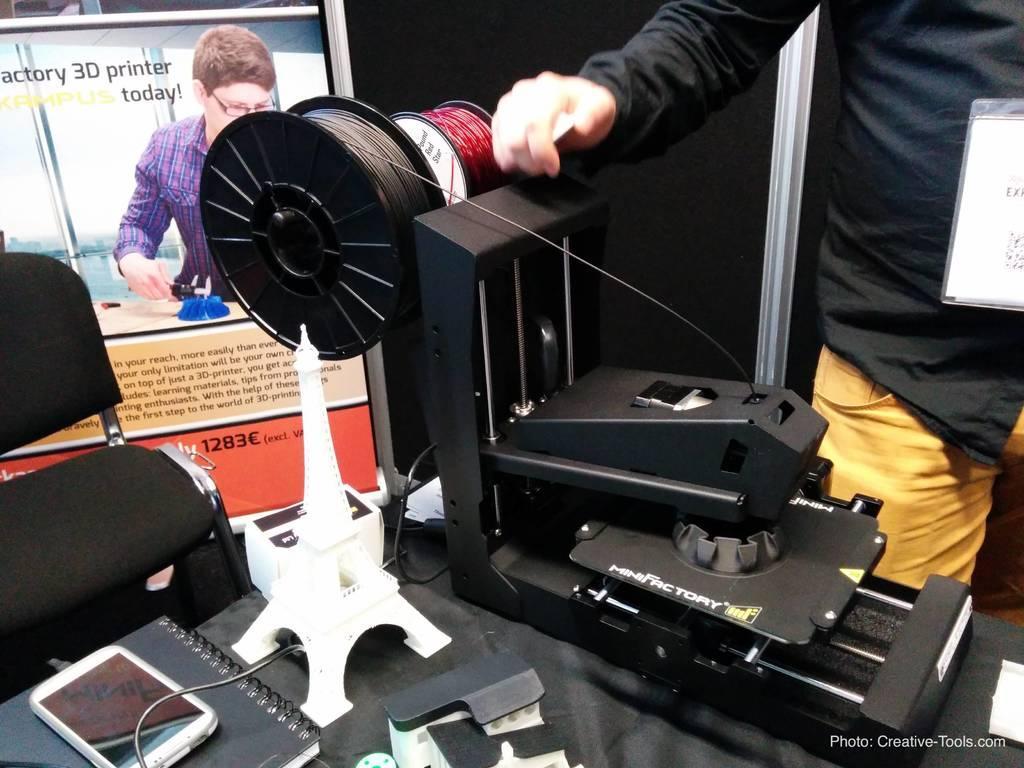Describe this image in one or two sentences. In this picture we can see a man standing, tower, mobile, machine, book, chair, poster, name board and some objects and in the background we can see the wall. 